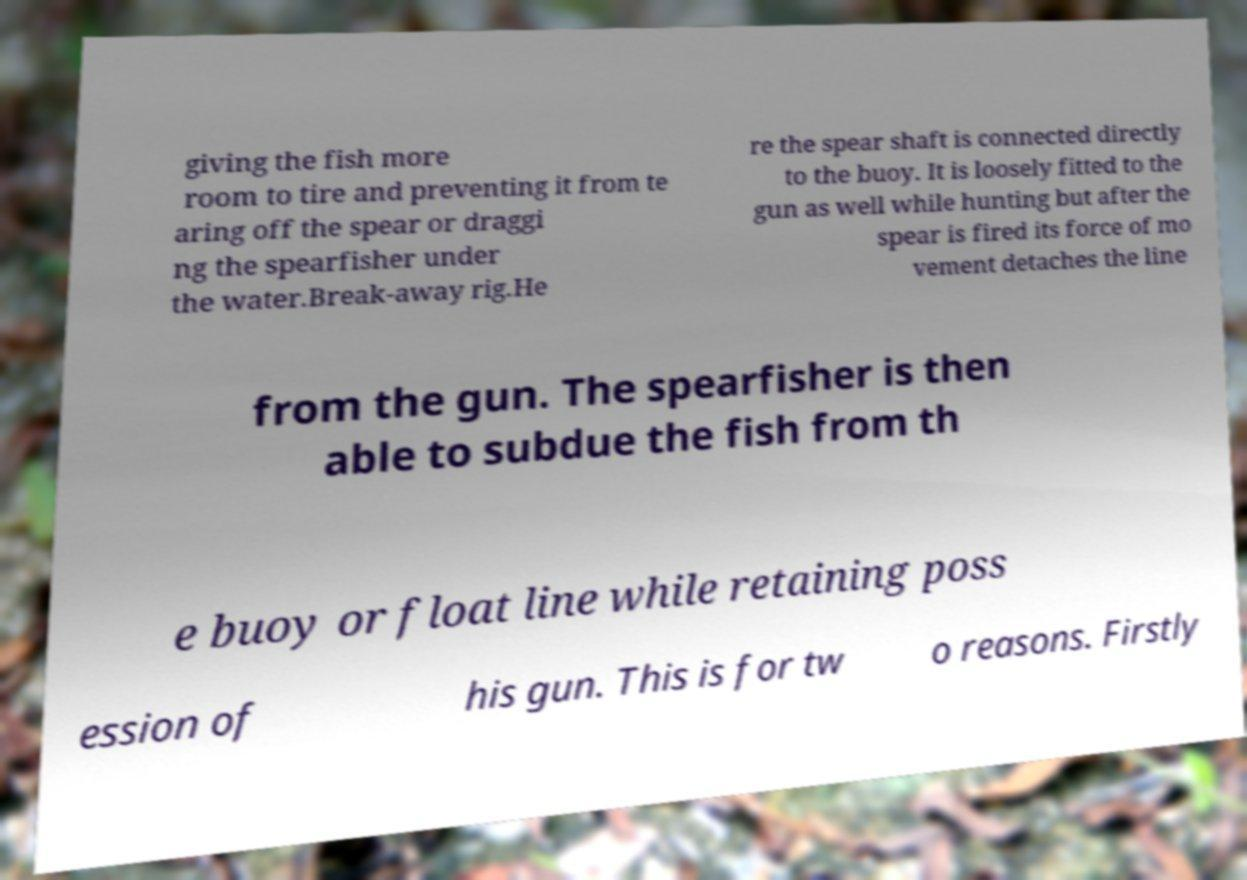Can you accurately transcribe the text from the provided image for me? giving the fish more room to tire and preventing it from te aring off the spear or draggi ng the spearfisher under the water.Break-away rig.He re the spear shaft is connected directly to the buoy. It is loosely fitted to the gun as well while hunting but after the spear is fired its force of mo vement detaches the line from the gun. The spearfisher is then able to subdue the fish from th e buoy or float line while retaining poss ession of his gun. This is for tw o reasons. Firstly 